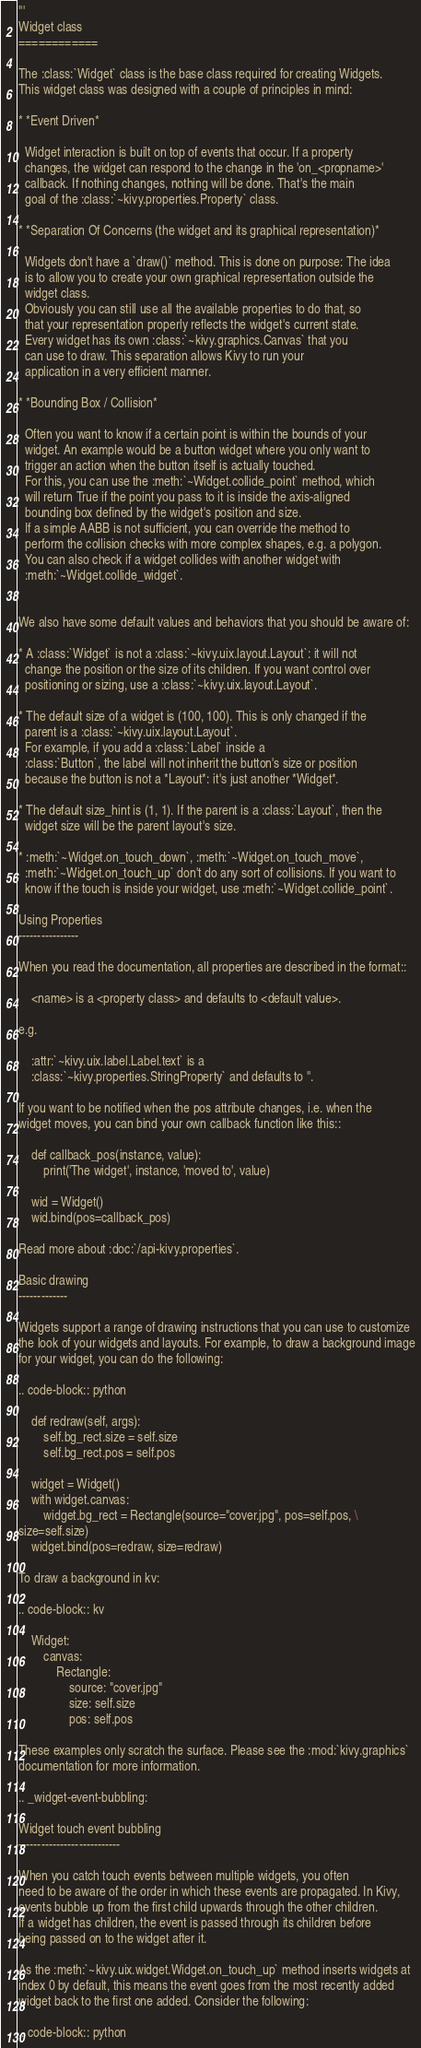<code> <loc_0><loc_0><loc_500><loc_500><_Python_>'''
Widget class
============

The :class:`Widget` class is the base class required for creating Widgets.
This widget class was designed with a couple of principles in mind:

* *Event Driven*

  Widget interaction is built on top of events that occur. If a property
  changes, the widget can respond to the change in the 'on_<propname>'
  callback. If nothing changes, nothing will be done. That's the main
  goal of the :class:`~kivy.properties.Property` class.

* *Separation Of Concerns (the widget and its graphical representation)*

  Widgets don't have a `draw()` method. This is done on purpose: The idea
  is to allow you to create your own graphical representation outside the
  widget class.
  Obviously you can still use all the available properties to do that, so
  that your representation properly reflects the widget's current state.
  Every widget has its own :class:`~kivy.graphics.Canvas` that you
  can use to draw. This separation allows Kivy to run your
  application in a very efficient manner.

* *Bounding Box / Collision*

  Often you want to know if a certain point is within the bounds of your
  widget. An example would be a button widget where you only want to
  trigger an action when the button itself is actually touched.
  For this, you can use the :meth:`~Widget.collide_point` method, which
  will return True if the point you pass to it is inside the axis-aligned
  bounding box defined by the widget's position and size.
  If a simple AABB is not sufficient, you can override the method to
  perform the collision checks with more complex shapes, e.g. a polygon.
  You can also check if a widget collides with another widget with
  :meth:`~Widget.collide_widget`.


We also have some default values and behaviors that you should be aware of:

* A :class:`Widget` is not a :class:`~kivy.uix.layout.Layout`: it will not
  change the position or the size of its children. If you want control over
  positioning or sizing, use a :class:`~kivy.uix.layout.Layout`.

* The default size of a widget is (100, 100). This is only changed if the
  parent is a :class:`~kivy.uix.layout.Layout`.
  For example, if you add a :class:`Label` inside a
  :class:`Button`, the label will not inherit the button's size or position
  because the button is not a *Layout*: it's just another *Widget*.

* The default size_hint is (1, 1). If the parent is a :class:`Layout`, then the
  widget size will be the parent layout's size.

* :meth:`~Widget.on_touch_down`, :meth:`~Widget.on_touch_move`,
  :meth:`~Widget.on_touch_up` don't do any sort of collisions. If you want to
  know if the touch is inside your widget, use :meth:`~Widget.collide_point`.

Using Properties
----------------

When you read the documentation, all properties are described in the format::

    <name> is a <property class> and defaults to <default value>.

e.g.

    :attr:`~kivy.uix.label.Label.text` is a
    :class:`~kivy.properties.StringProperty` and defaults to ''.

If you want to be notified when the pos attribute changes, i.e. when the
widget moves, you can bind your own callback function like this::

    def callback_pos(instance, value):
        print('The widget', instance, 'moved to', value)

    wid = Widget()
    wid.bind(pos=callback_pos)

Read more about :doc:`/api-kivy.properties`.

Basic drawing
-------------

Widgets support a range of drawing instructions that you can use to customize
the look of your widgets and layouts. For example, to draw a background image
for your widget, you can do the following:

.. code-block:: python

    def redraw(self, args):
        self.bg_rect.size = self.size
        self.bg_rect.pos = self.pos

    widget = Widget()
    with widget.canvas:
        widget.bg_rect = Rectangle(source="cover.jpg", pos=self.pos, \
size=self.size)
    widget.bind(pos=redraw, size=redraw)

To draw a background in kv:

.. code-block:: kv

    Widget:
        canvas:
            Rectangle:
                source: "cover.jpg"
                size: self.size
                pos: self.pos

These examples only scratch the surface. Please see the :mod:`kivy.graphics`
documentation for more information.

.. _widget-event-bubbling:

Widget touch event bubbling
---------------------------

When you catch touch events between multiple widgets, you often
need to be aware of the order in which these events are propagated. In Kivy,
events bubble up from the first child upwards through the other children.
If a widget has children, the event is passed through its children before
being passed on to the widget after it.

As the :meth:`~kivy.uix.widget.Widget.on_touch_up` method inserts widgets at
index 0 by default, this means the event goes from the most recently added
widget back to the first one added. Consider the following:

.. code-block:: python
</code> 